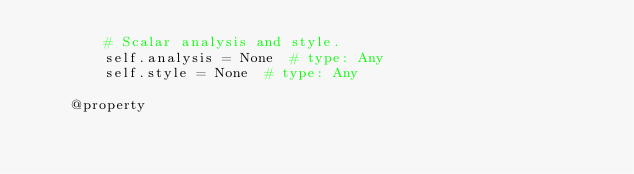Convert code to text. <code><loc_0><loc_0><loc_500><loc_500><_Python_>        # Scalar analysis and style.
        self.analysis = None  # type: Any
        self.style = None  # type: Any

    @property</code> 